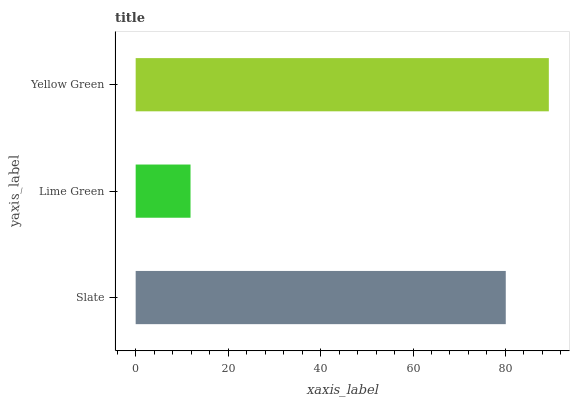Is Lime Green the minimum?
Answer yes or no. Yes. Is Yellow Green the maximum?
Answer yes or no. Yes. Is Yellow Green the minimum?
Answer yes or no. No. Is Lime Green the maximum?
Answer yes or no. No. Is Yellow Green greater than Lime Green?
Answer yes or no. Yes. Is Lime Green less than Yellow Green?
Answer yes or no. Yes. Is Lime Green greater than Yellow Green?
Answer yes or no. No. Is Yellow Green less than Lime Green?
Answer yes or no. No. Is Slate the high median?
Answer yes or no. Yes. Is Slate the low median?
Answer yes or no. Yes. Is Yellow Green the high median?
Answer yes or no. No. Is Yellow Green the low median?
Answer yes or no. No. 